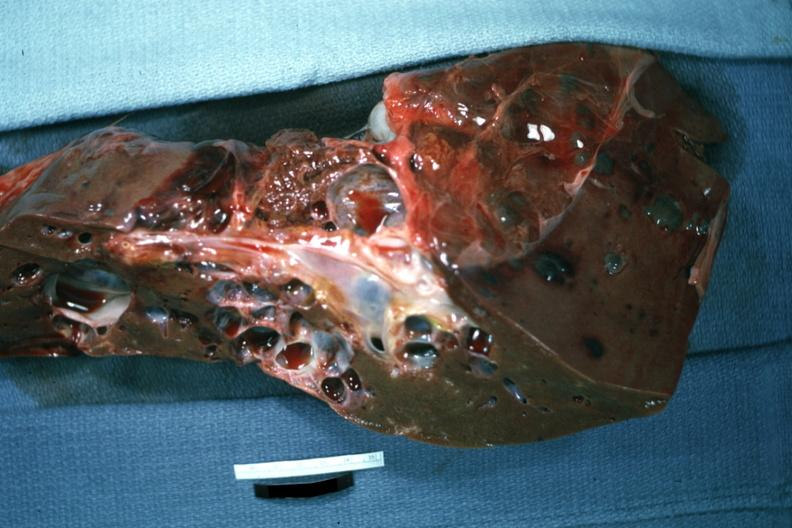how does this image show cut surface?
Answer the question using a single word or phrase. With many cysts case of polycystic disease 